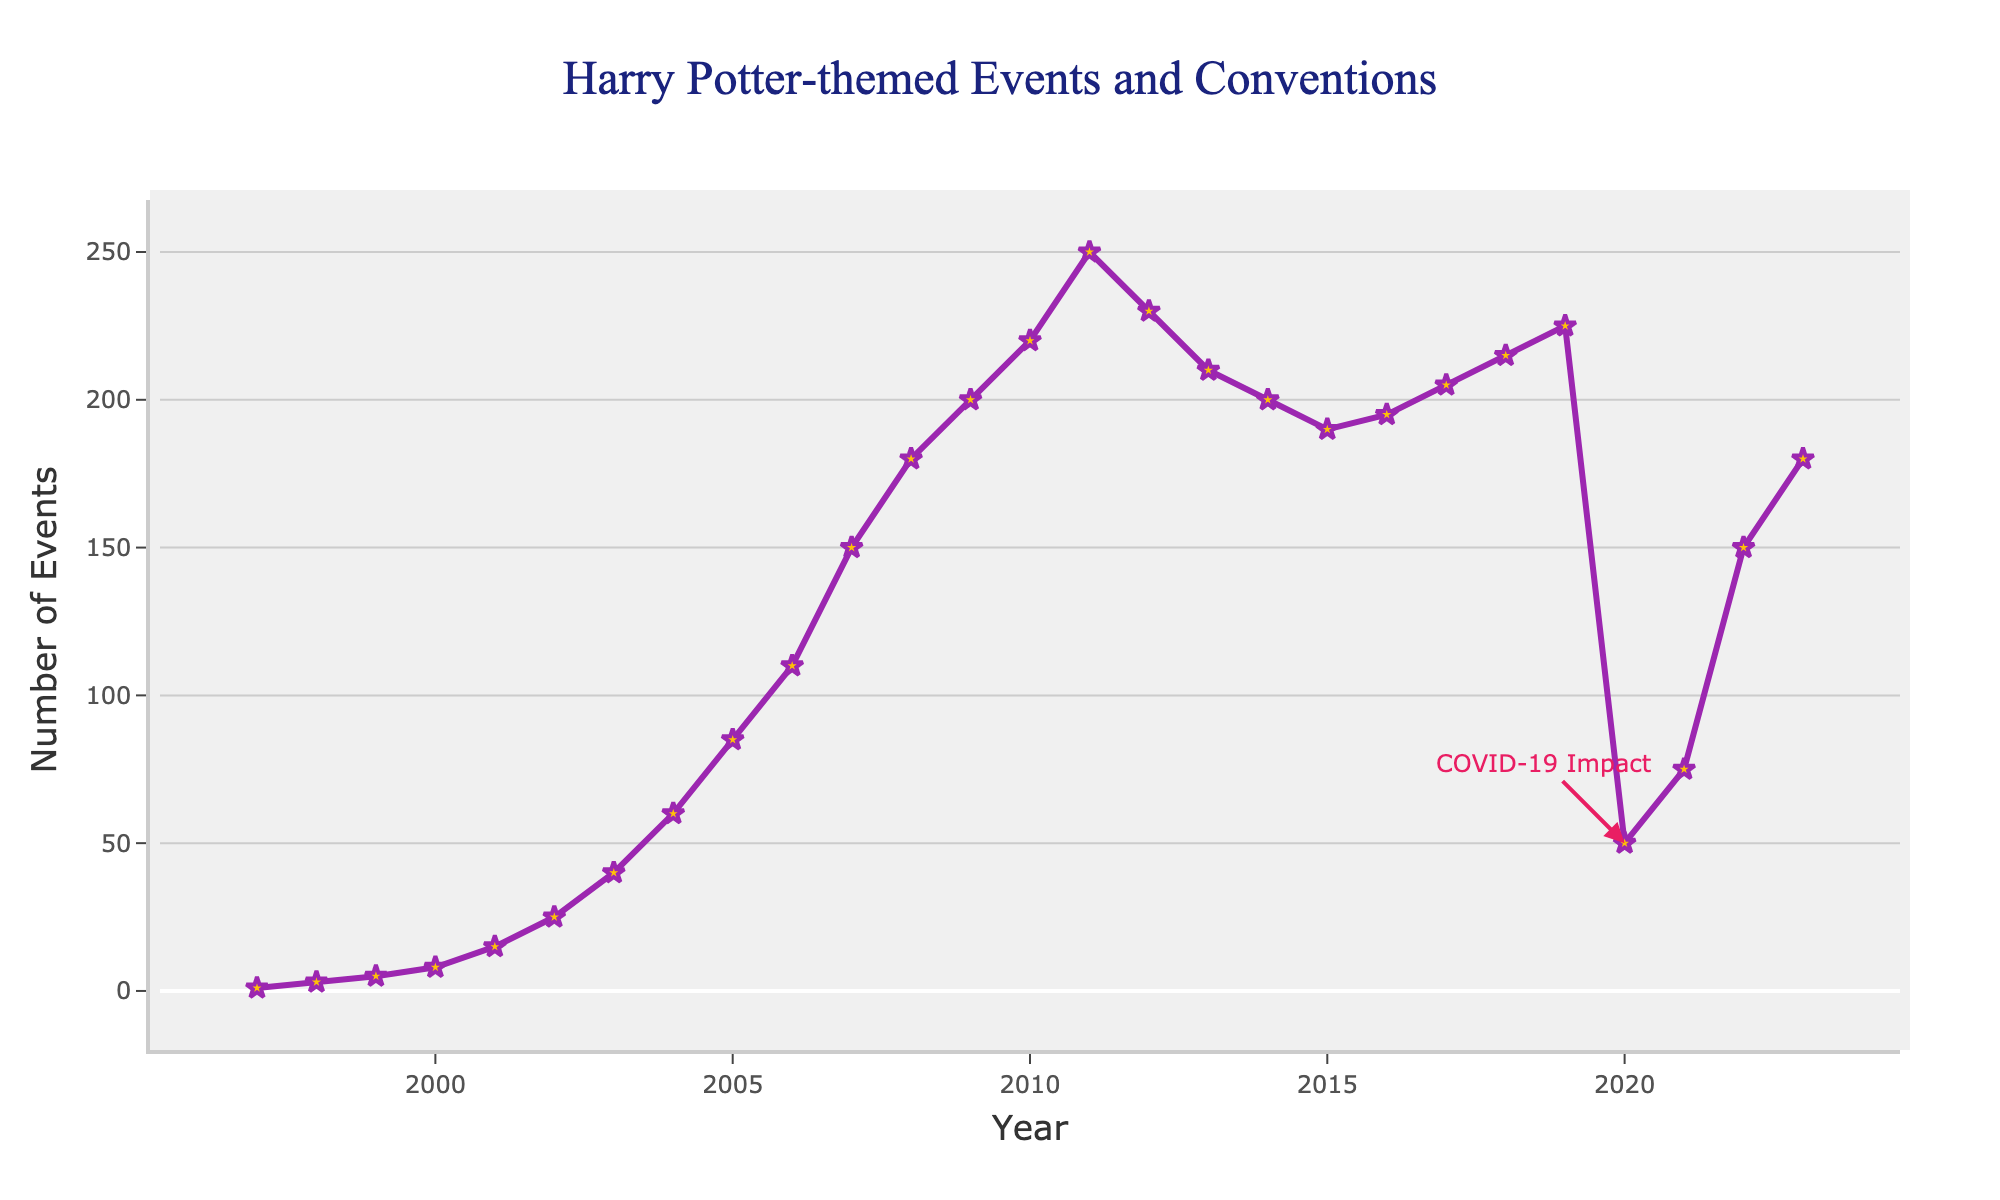How many events were held in 2005? From the chart, locate the year 2005 on the x-axis and find the corresponding value on the y-axis.
Answer: 85 Compare the number of events in 2011 and 2019. Which year had more events? Locate the points for the years 2011 and 2019 on the x-axis and compare the corresponding y-axis values.
Answer: 2011 What is the difference in the number of events between 2003 and 2007? Find the number of events for the years 2003 (40 events) and 2007 (150 events) on the y-axis, then subtract the smaller value from the larger one: 150 - 40.
Answer: 110 Identify the year with the highest number of events before the COVID-19 impact in 2020. Look at the plot and identify the highest data point on the y-axis to the left of the 2020 annotation. The highest point before COVID-19 is 2011 with 250 events.
Answer: 2011 Was there an increase or decrease in the number of events from 2015 to 2016? Find the number of events for 2015 (190 events) and 2016 (195 events) on the y-axis. Compare the values to determine the change.
Answer: Increase Calculate the average number of events held annually from 2010 to 2014. Sum the number of events from 2010 (220), 2011 (250), 2012 (230), 2013 (210), and 2014 (200), then divide by the number of years: (220 + 250 + 230 + 210 + 200) / 5.
Answer: 222 Describe the trend in the number of events from 1997 to 2007. Observe the plot from 1997 to 2007. The number of events generally increases each year, starting from 1 event in 1997 and reaching 150 events in 2007.
Answer: Increasing Find the year with the most significant decrease in the number of events and state the decrease amount. Identify the two consecutive years with the largest drop. In 2020, due to COVID-19, the decrease from 2019 (225) to 2020 (50) was the most significant: 225 - 50.
Answer: 2020, 175 What is the rate of change in the number of events between 2019 and 2021? Calculate the rate by finding the difference between the values for 2019 (225) and 2021 (75) and dividing by the number of years: (75 - 225) / (2021 - 2019).
Answer: -75 per year 